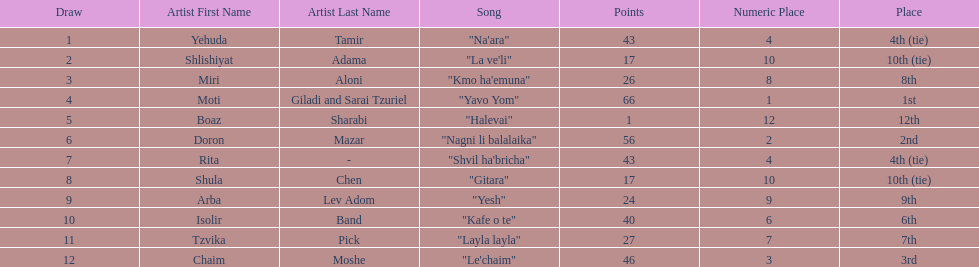What is the total amount of ties in this competition? 2. 